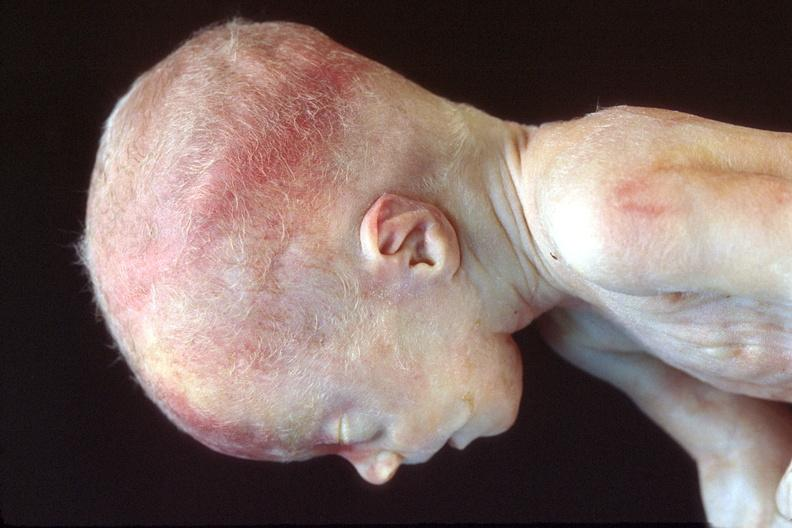does peritoneal fluid show hyaline membrane disease?
Answer the question using a single word or phrase. No 